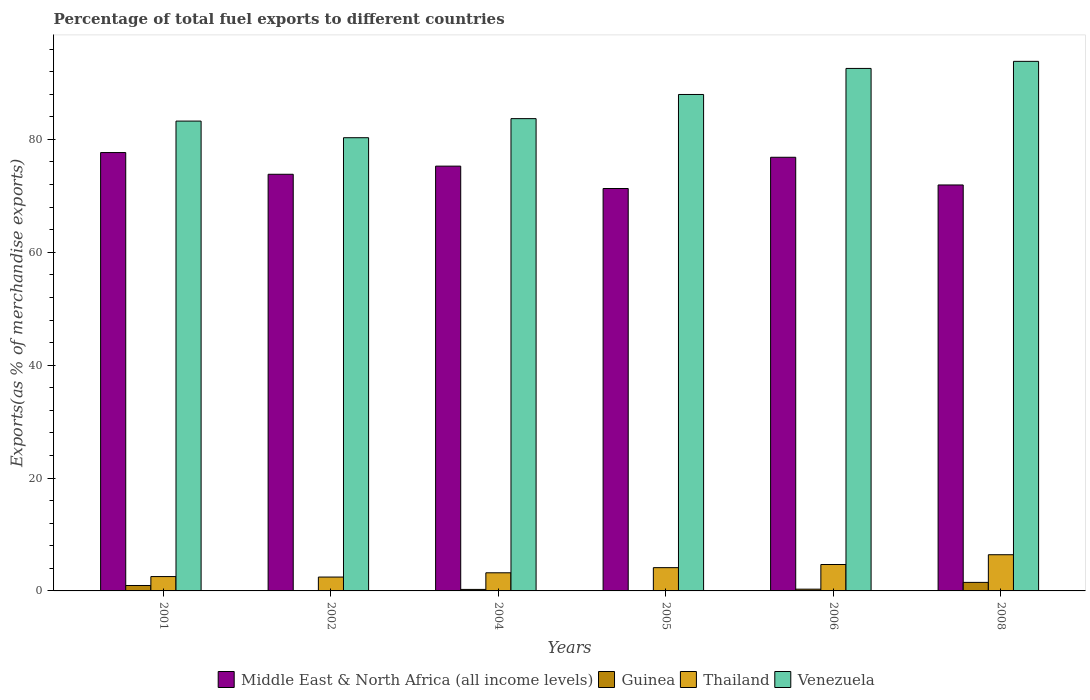How many bars are there on the 4th tick from the left?
Offer a terse response. 4. In how many cases, is the number of bars for a given year not equal to the number of legend labels?
Ensure brevity in your answer.  0. What is the percentage of exports to different countries in Middle East & North Africa (all income levels) in 2006?
Your answer should be compact. 76.83. Across all years, what is the maximum percentage of exports to different countries in Middle East & North Africa (all income levels)?
Provide a succinct answer. 77.67. Across all years, what is the minimum percentage of exports to different countries in Middle East & North Africa (all income levels)?
Give a very brief answer. 71.3. In which year was the percentage of exports to different countries in Venezuela maximum?
Provide a short and direct response. 2008. What is the total percentage of exports to different countries in Thailand in the graph?
Offer a terse response. 23.43. What is the difference between the percentage of exports to different countries in Thailand in 2001 and that in 2005?
Give a very brief answer. -1.58. What is the difference between the percentage of exports to different countries in Thailand in 2001 and the percentage of exports to different countries in Guinea in 2004?
Make the answer very short. 2.28. What is the average percentage of exports to different countries in Venezuela per year?
Offer a terse response. 86.93. In the year 2004, what is the difference between the percentage of exports to different countries in Thailand and percentage of exports to different countries in Venezuela?
Your answer should be compact. -80.47. In how many years, is the percentage of exports to different countries in Middle East & North Africa (all income levels) greater than 20 %?
Offer a terse response. 6. What is the ratio of the percentage of exports to different countries in Thailand in 2006 to that in 2008?
Keep it short and to the point. 0.73. Is the percentage of exports to different countries in Venezuela in 2001 less than that in 2008?
Offer a terse response. Yes. What is the difference between the highest and the second highest percentage of exports to different countries in Middle East & North Africa (all income levels)?
Ensure brevity in your answer.  0.84. What is the difference between the highest and the lowest percentage of exports to different countries in Thailand?
Offer a very short reply. 3.95. Is the sum of the percentage of exports to different countries in Thailand in 2004 and 2006 greater than the maximum percentage of exports to different countries in Guinea across all years?
Your answer should be compact. Yes. Is it the case that in every year, the sum of the percentage of exports to different countries in Venezuela and percentage of exports to different countries in Middle East & North Africa (all income levels) is greater than the sum of percentage of exports to different countries in Thailand and percentage of exports to different countries in Guinea?
Provide a succinct answer. No. What does the 1st bar from the left in 2008 represents?
Give a very brief answer. Middle East & North Africa (all income levels). What does the 3rd bar from the right in 2005 represents?
Make the answer very short. Guinea. Is it the case that in every year, the sum of the percentage of exports to different countries in Guinea and percentage of exports to different countries in Thailand is greater than the percentage of exports to different countries in Venezuela?
Give a very brief answer. No. How many years are there in the graph?
Your response must be concise. 6. Are the values on the major ticks of Y-axis written in scientific E-notation?
Provide a short and direct response. No. Does the graph contain any zero values?
Provide a succinct answer. No. Does the graph contain grids?
Make the answer very short. No. How many legend labels are there?
Offer a very short reply. 4. How are the legend labels stacked?
Make the answer very short. Horizontal. What is the title of the graph?
Offer a terse response. Percentage of total fuel exports to different countries. Does "Caribbean small states" appear as one of the legend labels in the graph?
Ensure brevity in your answer.  No. What is the label or title of the X-axis?
Make the answer very short. Years. What is the label or title of the Y-axis?
Ensure brevity in your answer.  Exports(as % of merchandise exports). What is the Exports(as % of merchandise exports) of Middle East & North Africa (all income levels) in 2001?
Provide a succinct answer. 77.67. What is the Exports(as % of merchandise exports) of Guinea in 2001?
Your answer should be compact. 0.96. What is the Exports(as % of merchandise exports) in Thailand in 2001?
Give a very brief answer. 2.54. What is the Exports(as % of merchandise exports) of Venezuela in 2001?
Your answer should be very brief. 83.24. What is the Exports(as % of merchandise exports) of Middle East & North Africa (all income levels) in 2002?
Keep it short and to the point. 73.82. What is the Exports(as % of merchandise exports) of Guinea in 2002?
Your answer should be compact. 0.07. What is the Exports(as % of merchandise exports) in Thailand in 2002?
Offer a terse response. 2.46. What is the Exports(as % of merchandise exports) of Venezuela in 2002?
Your answer should be compact. 80.3. What is the Exports(as % of merchandise exports) of Middle East & North Africa (all income levels) in 2004?
Keep it short and to the point. 75.26. What is the Exports(as % of merchandise exports) in Guinea in 2004?
Offer a very short reply. 0.27. What is the Exports(as % of merchandise exports) in Thailand in 2004?
Provide a short and direct response. 3.21. What is the Exports(as % of merchandise exports) of Venezuela in 2004?
Your response must be concise. 83.68. What is the Exports(as % of merchandise exports) in Middle East & North Africa (all income levels) in 2005?
Give a very brief answer. 71.3. What is the Exports(as % of merchandise exports) in Guinea in 2005?
Ensure brevity in your answer.  3.9069582544466e-5. What is the Exports(as % of merchandise exports) in Thailand in 2005?
Offer a terse response. 4.12. What is the Exports(as % of merchandise exports) of Venezuela in 2005?
Offer a terse response. 87.96. What is the Exports(as % of merchandise exports) in Middle East & North Africa (all income levels) in 2006?
Keep it short and to the point. 76.83. What is the Exports(as % of merchandise exports) in Guinea in 2006?
Ensure brevity in your answer.  0.31. What is the Exports(as % of merchandise exports) of Thailand in 2006?
Your answer should be compact. 4.68. What is the Exports(as % of merchandise exports) in Venezuela in 2006?
Ensure brevity in your answer.  92.57. What is the Exports(as % of merchandise exports) of Middle East & North Africa (all income levels) in 2008?
Provide a succinct answer. 71.93. What is the Exports(as % of merchandise exports) in Guinea in 2008?
Your answer should be very brief. 1.51. What is the Exports(as % of merchandise exports) in Thailand in 2008?
Your response must be concise. 6.41. What is the Exports(as % of merchandise exports) in Venezuela in 2008?
Give a very brief answer. 93.83. Across all years, what is the maximum Exports(as % of merchandise exports) of Middle East & North Africa (all income levels)?
Keep it short and to the point. 77.67. Across all years, what is the maximum Exports(as % of merchandise exports) in Guinea?
Provide a short and direct response. 1.51. Across all years, what is the maximum Exports(as % of merchandise exports) of Thailand?
Your response must be concise. 6.41. Across all years, what is the maximum Exports(as % of merchandise exports) of Venezuela?
Your response must be concise. 93.83. Across all years, what is the minimum Exports(as % of merchandise exports) of Middle East & North Africa (all income levels)?
Keep it short and to the point. 71.3. Across all years, what is the minimum Exports(as % of merchandise exports) in Guinea?
Keep it short and to the point. 3.9069582544466e-5. Across all years, what is the minimum Exports(as % of merchandise exports) in Thailand?
Give a very brief answer. 2.46. Across all years, what is the minimum Exports(as % of merchandise exports) in Venezuela?
Offer a terse response. 80.3. What is the total Exports(as % of merchandise exports) of Middle East & North Africa (all income levels) in the graph?
Make the answer very short. 446.81. What is the total Exports(as % of merchandise exports) in Guinea in the graph?
Your answer should be compact. 3.13. What is the total Exports(as % of merchandise exports) of Thailand in the graph?
Provide a short and direct response. 23.43. What is the total Exports(as % of merchandise exports) of Venezuela in the graph?
Your answer should be very brief. 521.58. What is the difference between the Exports(as % of merchandise exports) in Middle East & North Africa (all income levels) in 2001 and that in 2002?
Provide a succinct answer. 3.85. What is the difference between the Exports(as % of merchandise exports) in Guinea in 2001 and that in 2002?
Your response must be concise. 0.89. What is the difference between the Exports(as % of merchandise exports) of Thailand in 2001 and that in 2002?
Provide a succinct answer. 0.09. What is the difference between the Exports(as % of merchandise exports) in Venezuela in 2001 and that in 2002?
Provide a short and direct response. 2.94. What is the difference between the Exports(as % of merchandise exports) of Middle East & North Africa (all income levels) in 2001 and that in 2004?
Make the answer very short. 2.41. What is the difference between the Exports(as % of merchandise exports) in Guinea in 2001 and that in 2004?
Offer a very short reply. 0.69. What is the difference between the Exports(as % of merchandise exports) of Thailand in 2001 and that in 2004?
Provide a succinct answer. -0.67. What is the difference between the Exports(as % of merchandise exports) in Venezuela in 2001 and that in 2004?
Offer a very short reply. -0.44. What is the difference between the Exports(as % of merchandise exports) of Middle East & North Africa (all income levels) in 2001 and that in 2005?
Provide a succinct answer. 6.37. What is the difference between the Exports(as % of merchandise exports) of Guinea in 2001 and that in 2005?
Make the answer very short. 0.96. What is the difference between the Exports(as % of merchandise exports) in Thailand in 2001 and that in 2005?
Your answer should be very brief. -1.58. What is the difference between the Exports(as % of merchandise exports) of Venezuela in 2001 and that in 2005?
Provide a succinct answer. -4.71. What is the difference between the Exports(as % of merchandise exports) of Middle East & North Africa (all income levels) in 2001 and that in 2006?
Keep it short and to the point. 0.84. What is the difference between the Exports(as % of merchandise exports) of Guinea in 2001 and that in 2006?
Offer a terse response. 0.65. What is the difference between the Exports(as % of merchandise exports) of Thailand in 2001 and that in 2006?
Ensure brevity in your answer.  -2.13. What is the difference between the Exports(as % of merchandise exports) in Venezuela in 2001 and that in 2006?
Your response must be concise. -9.33. What is the difference between the Exports(as % of merchandise exports) in Middle East & North Africa (all income levels) in 2001 and that in 2008?
Offer a very short reply. 5.74. What is the difference between the Exports(as % of merchandise exports) in Guinea in 2001 and that in 2008?
Make the answer very short. -0.55. What is the difference between the Exports(as % of merchandise exports) in Thailand in 2001 and that in 2008?
Offer a terse response. -3.87. What is the difference between the Exports(as % of merchandise exports) in Venezuela in 2001 and that in 2008?
Provide a short and direct response. -10.58. What is the difference between the Exports(as % of merchandise exports) of Middle East & North Africa (all income levels) in 2002 and that in 2004?
Give a very brief answer. -1.44. What is the difference between the Exports(as % of merchandise exports) of Guinea in 2002 and that in 2004?
Keep it short and to the point. -0.19. What is the difference between the Exports(as % of merchandise exports) of Thailand in 2002 and that in 2004?
Keep it short and to the point. -0.76. What is the difference between the Exports(as % of merchandise exports) in Venezuela in 2002 and that in 2004?
Offer a very short reply. -3.38. What is the difference between the Exports(as % of merchandise exports) in Middle East & North Africa (all income levels) in 2002 and that in 2005?
Give a very brief answer. 2.52. What is the difference between the Exports(as % of merchandise exports) of Guinea in 2002 and that in 2005?
Give a very brief answer. 0.07. What is the difference between the Exports(as % of merchandise exports) of Thailand in 2002 and that in 2005?
Give a very brief answer. -1.67. What is the difference between the Exports(as % of merchandise exports) in Venezuela in 2002 and that in 2005?
Your answer should be very brief. -7.66. What is the difference between the Exports(as % of merchandise exports) in Middle East & North Africa (all income levels) in 2002 and that in 2006?
Give a very brief answer. -3.01. What is the difference between the Exports(as % of merchandise exports) in Guinea in 2002 and that in 2006?
Your answer should be compact. -0.24. What is the difference between the Exports(as % of merchandise exports) of Thailand in 2002 and that in 2006?
Provide a short and direct response. -2.22. What is the difference between the Exports(as % of merchandise exports) of Venezuela in 2002 and that in 2006?
Keep it short and to the point. -12.27. What is the difference between the Exports(as % of merchandise exports) in Middle East & North Africa (all income levels) in 2002 and that in 2008?
Offer a very short reply. 1.89. What is the difference between the Exports(as % of merchandise exports) of Guinea in 2002 and that in 2008?
Provide a short and direct response. -1.44. What is the difference between the Exports(as % of merchandise exports) of Thailand in 2002 and that in 2008?
Ensure brevity in your answer.  -3.95. What is the difference between the Exports(as % of merchandise exports) of Venezuela in 2002 and that in 2008?
Offer a very short reply. -13.53. What is the difference between the Exports(as % of merchandise exports) in Middle East & North Africa (all income levels) in 2004 and that in 2005?
Make the answer very short. 3.96. What is the difference between the Exports(as % of merchandise exports) of Guinea in 2004 and that in 2005?
Your answer should be compact. 0.27. What is the difference between the Exports(as % of merchandise exports) in Thailand in 2004 and that in 2005?
Offer a terse response. -0.91. What is the difference between the Exports(as % of merchandise exports) in Venezuela in 2004 and that in 2005?
Your answer should be very brief. -4.28. What is the difference between the Exports(as % of merchandise exports) in Middle East & North Africa (all income levels) in 2004 and that in 2006?
Offer a terse response. -1.57. What is the difference between the Exports(as % of merchandise exports) in Guinea in 2004 and that in 2006?
Your answer should be very brief. -0.04. What is the difference between the Exports(as % of merchandise exports) of Thailand in 2004 and that in 2006?
Make the answer very short. -1.47. What is the difference between the Exports(as % of merchandise exports) of Venezuela in 2004 and that in 2006?
Offer a very short reply. -8.89. What is the difference between the Exports(as % of merchandise exports) in Middle East & North Africa (all income levels) in 2004 and that in 2008?
Make the answer very short. 3.34. What is the difference between the Exports(as % of merchandise exports) of Guinea in 2004 and that in 2008?
Your answer should be very brief. -1.24. What is the difference between the Exports(as % of merchandise exports) in Thailand in 2004 and that in 2008?
Make the answer very short. -3.2. What is the difference between the Exports(as % of merchandise exports) in Venezuela in 2004 and that in 2008?
Make the answer very short. -10.15. What is the difference between the Exports(as % of merchandise exports) of Middle East & North Africa (all income levels) in 2005 and that in 2006?
Provide a short and direct response. -5.53. What is the difference between the Exports(as % of merchandise exports) in Guinea in 2005 and that in 2006?
Provide a short and direct response. -0.31. What is the difference between the Exports(as % of merchandise exports) in Thailand in 2005 and that in 2006?
Keep it short and to the point. -0.56. What is the difference between the Exports(as % of merchandise exports) of Venezuela in 2005 and that in 2006?
Keep it short and to the point. -4.62. What is the difference between the Exports(as % of merchandise exports) of Middle East & North Africa (all income levels) in 2005 and that in 2008?
Provide a short and direct response. -0.63. What is the difference between the Exports(as % of merchandise exports) in Guinea in 2005 and that in 2008?
Ensure brevity in your answer.  -1.51. What is the difference between the Exports(as % of merchandise exports) of Thailand in 2005 and that in 2008?
Provide a succinct answer. -2.29. What is the difference between the Exports(as % of merchandise exports) in Venezuela in 2005 and that in 2008?
Offer a terse response. -5.87. What is the difference between the Exports(as % of merchandise exports) in Middle East & North Africa (all income levels) in 2006 and that in 2008?
Provide a short and direct response. 4.91. What is the difference between the Exports(as % of merchandise exports) of Guinea in 2006 and that in 2008?
Provide a short and direct response. -1.2. What is the difference between the Exports(as % of merchandise exports) in Thailand in 2006 and that in 2008?
Your answer should be very brief. -1.73. What is the difference between the Exports(as % of merchandise exports) in Venezuela in 2006 and that in 2008?
Give a very brief answer. -1.25. What is the difference between the Exports(as % of merchandise exports) of Middle East & North Africa (all income levels) in 2001 and the Exports(as % of merchandise exports) of Guinea in 2002?
Offer a very short reply. 77.6. What is the difference between the Exports(as % of merchandise exports) in Middle East & North Africa (all income levels) in 2001 and the Exports(as % of merchandise exports) in Thailand in 2002?
Your response must be concise. 75.21. What is the difference between the Exports(as % of merchandise exports) of Middle East & North Africa (all income levels) in 2001 and the Exports(as % of merchandise exports) of Venezuela in 2002?
Keep it short and to the point. -2.63. What is the difference between the Exports(as % of merchandise exports) of Guinea in 2001 and the Exports(as % of merchandise exports) of Thailand in 2002?
Give a very brief answer. -1.49. What is the difference between the Exports(as % of merchandise exports) of Guinea in 2001 and the Exports(as % of merchandise exports) of Venezuela in 2002?
Make the answer very short. -79.34. What is the difference between the Exports(as % of merchandise exports) in Thailand in 2001 and the Exports(as % of merchandise exports) in Venezuela in 2002?
Ensure brevity in your answer.  -77.76. What is the difference between the Exports(as % of merchandise exports) in Middle East & North Africa (all income levels) in 2001 and the Exports(as % of merchandise exports) in Guinea in 2004?
Offer a terse response. 77.4. What is the difference between the Exports(as % of merchandise exports) in Middle East & North Africa (all income levels) in 2001 and the Exports(as % of merchandise exports) in Thailand in 2004?
Your answer should be very brief. 74.46. What is the difference between the Exports(as % of merchandise exports) in Middle East & North Africa (all income levels) in 2001 and the Exports(as % of merchandise exports) in Venezuela in 2004?
Your answer should be compact. -6.01. What is the difference between the Exports(as % of merchandise exports) of Guinea in 2001 and the Exports(as % of merchandise exports) of Thailand in 2004?
Give a very brief answer. -2.25. What is the difference between the Exports(as % of merchandise exports) of Guinea in 2001 and the Exports(as % of merchandise exports) of Venezuela in 2004?
Give a very brief answer. -82.72. What is the difference between the Exports(as % of merchandise exports) in Thailand in 2001 and the Exports(as % of merchandise exports) in Venezuela in 2004?
Your response must be concise. -81.14. What is the difference between the Exports(as % of merchandise exports) of Middle East & North Africa (all income levels) in 2001 and the Exports(as % of merchandise exports) of Guinea in 2005?
Provide a short and direct response. 77.67. What is the difference between the Exports(as % of merchandise exports) of Middle East & North Africa (all income levels) in 2001 and the Exports(as % of merchandise exports) of Thailand in 2005?
Provide a succinct answer. 73.55. What is the difference between the Exports(as % of merchandise exports) in Middle East & North Africa (all income levels) in 2001 and the Exports(as % of merchandise exports) in Venezuela in 2005?
Provide a succinct answer. -10.29. What is the difference between the Exports(as % of merchandise exports) of Guinea in 2001 and the Exports(as % of merchandise exports) of Thailand in 2005?
Your response must be concise. -3.16. What is the difference between the Exports(as % of merchandise exports) in Guinea in 2001 and the Exports(as % of merchandise exports) in Venezuela in 2005?
Keep it short and to the point. -87. What is the difference between the Exports(as % of merchandise exports) of Thailand in 2001 and the Exports(as % of merchandise exports) of Venezuela in 2005?
Your response must be concise. -85.41. What is the difference between the Exports(as % of merchandise exports) of Middle East & North Africa (all income levels) in 2001 and the Exports(as % of merchandise exports) of Guinea in 2006?
Offer a terse response. 77.36. What is the difference between the Exports(as % of merchandise exports) in Middle East & North Africa (all income levels) in 2001 and the Exports(as % of merchandise exports) in Thailand in 2006?
Give a very brief answer. 72.99. What is the difference between the Exports(as % of merchandise exports) in Middle East & North Africa (all income levels) in 2001 and the Exports(as % of merchandise exports) in Venezuela in 2006?
Offer a terse response. -14.9. What is the difference between the Exports(as % of merchandise exports) of Guinea in 2001 and the Exports(as % of merchandise exports) of Thailand in 2006?
Keep it short and to the point. -3.72. What is the difference between the Exports(as % of merchandise exports) of Guinea in 2001 and the Exports(as % of merchandise exports) of Venezuela in 2006?
Provide a short and direct response. -91.61. What is the difference between the Exports(as % of merchandise exports) in Thailand in 2001 and the Exports(as % of merchandise exports) in Venezuela in 2006?
Provide a succinct answer. -90.03. What is the difference between the Exports(as % of merchandise exports) of Middle East & North Africa (all income levels) in 2001 and the Exports(as % of merchandise exports) of Guinea in 2008?
Keep it short and to the point. 76.16. What is the difference between the Exports(as % of merchandise exports) in Middle East & North Africa (all income levels) in 2001 and the Exports(as % of merchandise exports) in Thailand in 2008?
Ensure brevity in your answer.  71.26. What is the difference between the Exports(as % of merchandise exports) in Middle East & North Africa (all income levels) in 2001 and the Exports(as % of merchandise exports) in Venezuela in 2008?
Your answer should be compact. -16.16. What is the difference between the Exports(as % of merchandise exports) of Guinea in 2001 and the Exports(as % of merchandise exports) of Thailand in 2008?
Your response must be concise. -5.45. What is the difference between the Exports(as % of merchandise exports) of Guinea in 2001 and the Exports(as % of merchandise exports) of Venezuela in 2008?
Provide a short and direct response. -92.87. What is the difference between the Exports(as % of merchandise exports) of Thailand in 2001 and the Exports(as % of merchandise exports) of Venezuela in 2008?
Offer a terse response. -91.28. What is the difference between the Exports(as % of merchandise exports) of Middle East & North Africa (all income levels) in 2002 and the Exports(as % of merchandise exports) of Guinea in 2004?
Provide a short and direct response. 73.55. What is the difference between the Exports(as % of merchandise exports) in Middle East & North Africa (all income levels) in 2002 and the Exports(as % of merchandise exports) in Thailand in 2004?
Ensure brevity in your answer.  70.61. What is the difference between the Exports(as % of merchandise exports) of Middle East & North Africa (all income levels) in 2002 and the Exports(as % of merchandise exports) of Venezuela in 2004?
Your answer should be compact. -9.86. What is the difference between the Exports(as % of merchandise exports) of Guinea in 2002 and the Exports(as % of merchandise exports) of Thailand in 2004?
Your answer should be very brief. -3.14. What is the difference between the Exports(as % of merchandise exports) in Guinea in 2002 and the Exports(as % of merchandise exports) in Venezuela in 2004?
Your answer should be compact. -83.61. What is the difference between the Exports(as % of merchandise exports) in Thailand in 2002 and the Exports(as % of merchandise exports) in Venezuela in 2004?
Give a very brief answer. -81.22. What is the difference between the Exports(as % of merchandise exports) of Middle East & North Africa (all income levels) in 2002 and the Exports(as % of merchandise exports) of Guinea in 2005?
Your answer should be very brief. 73.82. What is the difference between the Exports(as % of merchandise exports) in Middle East & North Africa (all income levels) in 2002 and the Exports(as % of merchandise exports) in Thailand in 2005?
Give a very brief answer. 69.7. What is the difference between the Exports(as % of merchandise exports) in Middle East & North Africa (all income levels) in 2002 and the Exports(as % of merchandise exports) in Venezuela in 2005?
Offer a terse response. -14.14. What is the difference between the Exports(as % of merchandise exports) of Guinea in 2002 and the Exports(as % of merchandise exports) of Thailand in 2005?
Make the answer very short. -4.05. What is the difference between the Exports(as % of merchandise exports) of Guinea in 2002 and the Exports(as % of merchandise exports) of Venezuela in 2005?
Offer a very short reply. -87.88. What is the difference between the Exports(as % of merchandise exports) of Thailand in 2002 and the Exports(as % of merchandise exports) of Venezuela in 2005?
Offer a very short reply. -85.5. What is the difference between the Exports(as % of merchandise exports) of Middle East & North Africa (all income levels) in 2002 and the Exports(as % of merchandise exports) of Guinea in 2006?
Offer a very short reply. 73.51. What is the difference between the Exports(as % of merchandise exports) of Middle East & North Africa (all income levels) in 2002 and the Exports(as % of merchandise exports) of Thailand in 2006?
Keep it short and to the point. 69.14. What is the difference between the Exports(as % of merchandise exports) in Middle East & North Africa (all income levels) in 2002 and the Exports(as % of merchandise exports) in Venezuela in 2006?
Make the answer very short. -18.75. What is the difference between the Exports(as % of merchandise exports) in Guinea in 2002 and the Exports(as % of merchandise exports) in Thailand in 2006?
Your answer should be very brief. -4.61. What is the difference between the Exports(as % of merchandise exports) in Guinea in 2002 and the Exports(as % of merchandise exports) in Venezuela in 2006?
Your answer should be very brief. -92.5. What is the difference between the Exports(as % of merchandise exports) of Thailand in 2002 and the Exports(as % of merchandise exports) of Venezuela in 2006?
Make the answer very short. -90.12. What is the difference between the Exports(as % of merchandise exports) of Middle East & North Africa (all income levels) in 2002 and the Exports(as % of merchandise exports) of Guinea in 2008?
Make the answer very short. 72.31. What is the difference between the Exports(as % of merchandise exports) in Middle East & North Africa (all income levels) in 2002 and the Exports(as % of merchandise exports) in Thailand in 2008?
Give a very brief answer. 67.41. What is the difference between the Exports(as % of merchandise exports) in Middle East & North Africa (all income levels) in 2002 and the Exports(as % of merchandise exports) in Venezuela in 2008?
Offer a very short reply. -20.01. What is the difference between the Exports(as % of merchandise exports) in Guinea in 2002 and the Exports(as % of merchandise exports) in Thailand in 2008?
Provide a short and direct response. -6.34. What is the difference between the Exports(as % of merchandise exports) of Guinea in 2002 and the Exports(as % of merchandise exports) of Venezuela in 2008?
Give a very brief answer. -93.75. What is the difference between the Exports(as % of merchandise exports) of Thailand in 2002 and the Exports(as % of merchandise exports) of Venezuela in 2008?
Provide a succinct answer. -91.37. What is the difference between the Exports(as % of merchandise exports) in Middle East & North Africa (all income levels) in 2004 and the Exports(as % of merchandise exports) in Guinea in 2005?
Keep it short and to the point. 75.26. What is the difference between the Exports(as % of merchandise exports) of Middle East & North Africa (all income levels) in 2004 and the Exports(as % of merchandise exports) of Thailand in 2005?
Provide a succinct answer. 71.14. What is the difference between the Exports(as % of merchandise exports) in Middle East & North Africa (all income levels) in 2004 and the Exports(as % of merchandise exports) in Venezuela in 2005?
Ensure brevity in your answer.  -12.7. What is the difference between the Exports(as % of merchandise exports) in Guinea in 2004 and the Exports(as % of merchandise exports) in Thailand in 2005?
Your answer should be very brief. -3.85. What is the difference between the Exports(as % of merchandise exports) in Guinea in 2004 and the Exports(as % of merchandise exports) in Venezuela in 2005?
Provide a short and direct response. -87.69. What is the difference between the Exports(as % of merchandise exports) in Thailand in 2004 and the Exports(as % of merchandise exports) in Venezuela in 2005?
Keep it short and to the point. -84.75. What is the difference between the Exports(as % of merchandise exports) of Middle East & North Africa (all income levels) in 2004 and the Exports(as % of merchandise exports) of Guinea in 2006?
Provide a succinct answer. 74.95. What is the difference between the Exports(as % of merchandise exports) in Middle East & North Africa (all income levels) in 2004 and the Exports(as % of merchandise exports) in Thailand in 2006?
Offer a very short reply. 70.58. What is the difference between the Exports(as % of merchandise exports) in Middle East & North Africa (all income levels) in 2004 and the Exports(as % of merchandise exports) in Venezuela in 2006?
Your response must be concise. -17.31. What is the difference between the Exports(as % of merchandise exports) in Guinea in 2004 and the Exports(as % of merchandise exports) in Thailand in 2006?
Your answer should be compact. -4.41. What is the difference between the Exports(as % of merchandise exports) of Guinea in 2004 and the Exports(as % of merchandise exports) of Venezuela in 2006?
Give a very brief answer. -92.31. What is the difference between the Exports(as % of merchandise exports) in Thailand in 2004 and the Exports(as % of merchandise exports) in Venezuela in 2006?
Offer a terse response. -89.36. What is the difference between the Exports(as % of merchandise exports) in Middle East & North Africa (all income levels) in 2004 and the Exports(as % of merchandise exports) in Guinea in 2008?
Provide a succinct answer. 73.75. What is the difference between the Exports(as % of merchandise exports) in Middle East & North Africa (all income levels) in 2004 and the Exports(as % of merchandise exports) in Thailand in 2008?
Keep it short and to the point. 68.85. What is the difference between the Exports(as % of merchandise exports) of Middle East & North Africa (all income levels) in 2004 and the Exports(as % of merchandise exports) of Venezuela in 2008?
Offer a very short reply. -18.57. What is the difference between the Exports(as % of merchandise exports) of Guinea in 2004 and the Exports(as % of merchandise exports) of Thailand in 2008?
Give a very brief answer. -6.14. What is the difference between the Exports(as % of merchandise exports) in Guinea in 2004 and the Exports(as % of merchandise exports) in Venezuela in 2008?
Offer a very short reply. -93.56. What is the difference between the Exports(as % of merchandise exports) of Thailand in 2004 and the Exports(as % of merchandise exports) of Venezuela in 2008?
Provide a succinct answer. -90.61. What is the difference between the Exports(as % of merchandise exports) of Middle East & North Africa (all income levels) in 2005 and the Exports(as % of merchandise exports) of Guinea in 2006?
Give a very brief answer. 70.99. What is the difference between the Exports(as % of merchandise exports) in Middle East & North Africa (all income levels) in 2005 and the Exports(as % of merchandise exports) in Thailand in 2006?
Your response must be concise. 66.62. What is the difference between the Exports(as % of merchandise exports) in Middle East & North Africa (all income levels) in 2005 and the Exports(as % of merchandise exports) in Venezuela in 2006?
Your response must be concise. -21.27. What is the difference between the Exports(as % of merchandise exports) of Guinea in 2005 and the Exports(as % of merchandise exports) of Thailand in 2006?
Give a very brief answer. -4.68. What is the difference between the Exports(as % of merchandise exports) in Guinea in 2005 and the Exports(as % of merchandise exports) in Venezuela in 2006?
Ensure brevity in your answer.  -92.57. What is the difference between the Exports(as % of merchandise exports) in Thailand in 2005 and the Exports(as % of merchandise exports) in Venezuela in 2006?
Give a very brief answer. -88.45. What is the difference between the Exports(as % of merchandise exports) of Middle East & North Africa (all income levels) in 2005 and the Exports(as % of merchandise exports) of Guinea in 2008?
Your answer should be very brief. 69.79. What is the difference between the Exports(as % of merchandise exports) in Middle East & North Africa (all income levels) in 2005 and the Exports(as % of merchandise exports) in Thailand in 2008?
Ensure brevity in your answer.  64.89. What is the difference between the Exports(as % of merchandise exports) in Middle East & North Africa (all income levels) in 2005 and the Exports(as % of merchandise exports) in Venezuela in 2008?
Provide a succinct answer. -22.53. What is the difference between the Exports(as % of merchandise exports) in Guinea in 2005 and the Exports(as % of merchandise exports) in Thailand in 2008?
Ensure brevity in your answer.  -6.41. What is the difference between the Exports(as % of merchandise exports) in Guinea in 2005 and the Exports(as % of merchandise exports) in Venezuela in 2008?
Give a very brief answer. -93.83. What is the difference between the Exports(as % of merchandise exports) of Thailand in 2005 and the Exports(as % of merchandise exports) of Venezuela in 2008?
Your response must be concise. -89.71. What is the difference between the Exports(as % of merchandise exports) in Middle East & North Africa (all income levels) in 2006 and the Exports(as % of merchandise exports) in Guinea in 2008?
Ensure brevity in your answer.  75.32. What is the difference between the Exports(as % of merchandise exports) of Middle East & North Africa (all income levels) in 2006 and the Exports(as % of merchandise exports) of Thailand in 2008?
Ensure brevity in your answer.  70.42. What is the difference between the Exports(as % of merchandise exports) in Middle East & North Africa (all income levels) in 2006 and the Exports(as % of merchandise exports) in Venezuela in 2008?
Give a very brief answer. -17. What is the difference between the Exports(as % of merchandise exports) of Guinea in 2006 and the Exports(as % of merchandise exports) of Thailand in 2008?
Offer a terse response. -6.1. What is the difference between the Exports(as % of merchandise exports) in Guinea in 2006 and the Exports(as % of merchandise exports) in Venezuela in 2008?
Ensure brevity in your answer.  -93.52. What is the difference between the Exports(as % of merchandise exports) of Thailand in 2006 and the Exports(as % of merchandise exports) of Venezuela in 2008?
Offer a very short reply. -89.15. What is the average Exports(as % of merchandise exports) in Middle East & North Africa (all income levels) per year?
Ensure brevity in your answer.  74.47. What is the average Exports(as % of merchandise exports) in Guinea per year?
Offer a very short reply. 0.52. What is the average Exports(as % of merchandise exports) of Thailand per year?
Offer a terse response. 3.9. What is the average Exports(as % of merchandise exports) of Venezuela per year?
Ensure brevity in your answer.  86.93. In the year 2001, what is the difference between the Exports(as % of merchandise exports) in Middle East & North Africa (all income levels) and Exports(as % of merchandise exports) in Guinea?
Provide a short and direct response. 76.71. In the year 2001, what is the difference between the Exports(as % of merchandise exports) of Middle East & North Africa (all income levels) and Exports(as % of merchandise exports) of Thailand?
Provide a succinct answer. 75.12. In the year 2001, what is the difference between the Exports(as % of merchandise exports) of Middle East & North Africa (all income levels) and Exports(as % of merchandise exports) of Venezuela?
Keep it short and to the point. -5.57. In the year 2001, what is the difference between the Exports(as % of merchandise exports) in Guinea and Exports(as % of merchandise exports) in Thailand?
Your answer should be very brief. -1.58. In the year 2001, what is the difference between the Exports(as % of merchandise exports) of Guinea and Exports(as % of merchandise exports) of Venezuela?
Your answer should be very brief. -82.28. In the year 2001, what is the difference between the Exports(as % of merchandise exports) in Thailand and Exports(as % of merchandise exports) in Venezuela?
Provide a succinct answer. -80.7. In the year 2002, what is the difference between the Exports(as % of merchandise exports) of Middle East & North Africa (all income levels) and Exports(as % of merchandise exports) of Guinea?
Ensure brevity in your answer.  73.75. In the year 2002, what is the difference between the Exports(as % of merchandise exports) in Middle East & North Africa (all income levels) and Exports(as % of merchandise exports) in Thailand?
Provide a short and direct response. 71.36. In the year 2002, what is the difference between the Exports(as % of merchandise exports) in Middle East & North Africa (all income levels) and Exports(as % of merchandise exports) in Venezuela?
Make the answer very short. -6.48. In the year 2002, what is the difference between the Exports(as % of merchandise exports) of Guinea and Exports(as % of merchandise exports) of Thailand?
Your response must be concise. -2.38. In the year 2002, what is the difference between the Exports(as % of merchandise exports) in Guinea and Exports(as % of merchandise exports) in Venezuela?
Offer a terse response. -80.23. In the year 2002, what is the difference between the Exports(as % of merchandise exports) in Thailand and Exports(as % of merchandise exports) in Venezuela?
Your response must be concise. -77.84. In the year 2004, what is the difference between the Exports(as % of merchandise exports) in Middle East & North Africa (all income levels) and Exports(as % of merchandise exports) in Guinea?
Provide a short and direct response. 74.99. In the year 2004, what is the difference between the Exports(as % of merchandise exports) of Middle East & North Africa (all income levels) and Exports(as % of merchandise exports) of Thailand?
Your answer should be very brief. 72.05. In the year 2004, what is the difference between the Exports(as % of merchandise exports) in Middle East & North Africa (all income levels) and Exports(as % of merchandise exports) in Venezuela?
Your response must be concise. -8.42. In the year 2004, what is the difference between the Exports(as % of merchandise exports) of Guinea and Exports(as % of merchandise exports) of Thailand?
Ensure brevity in your answer.  -2.94. In the year 2004, what is the difference between the Exports(as % of merchandise exports) of Guinea and Exports(as % of merchandise exports) of Venezuela?
Offer a terse response. -83.41. In the year 2004, what is the difference between the Exports(as % of merchandise exports) of Thailand and Exports(as % of merchandise exports) of Venezuela?
Give a very brief answer. -80.47. In the year 2005, what is the difference between the Exports(as % of merchandise exports) in Middle East & North Africa (all income levels) and Exports(as % of merchandise exports) in Guinea?
Offer a very short reply. 71.3. In the year 2005, what is the difference between the Exports(as % of merchandise exports) of Middle East & North Africa (all income levels) and Exports(as % of merchandise exports) of Thailand?
Your answer should be compact. 67.18. In the year 2005, what is the difference between the Exports(as % of merchandise exports) of Middle East & North Africa (all income levels) and Exports(as % of merchandise exports) of Venezuela?
Your answer should be compact. -16.66. In the year 2005, what is the difference between the Exports(as % of merchandise exports) in Guinea and Exports(as % of merchandise exports) in Thailand?
Provide a succinct answer. -4.12. In the year 2005, what is the difference between the Exports(as % of merchandise exports) in Guinea and Exports(as % of merchandise exports) in Venezuela?
Your answer should be very brief. -87.96. In the year 2005, what is the difference between the Exports(as % of merchandise exports) in Thailand and Exports(as % of merchandise exports) in Venezuela?
Offer a terse response. -83.84. In the year 2006, what is the difference between the Exports(as % of merchandise exports) in Middle East & North Africa (all income levels) and Exports(as % of merchandise exports) in Guinea?
Make the answer very short. 76.52. In the year 2006, what is the difference between the Exports(as % of merchandise exports) in Middle East & North Africa (all income levels) and Exports(as % of merchandise exports) in Thailand?
Keep it short and to the point. 72.15. In the year 2006, what is the difference between the Exports(as % of merchandise exports) in Middle East & North Africa (all income levels) and Exports(as % of merchandise exports) in Venezuela?
Your response must be concise. -15.74. In the year 2006, what is the difference between the Exports(as % of merchandise exports) in Guinea and Exports(as % of merchandise exports) in Thailand?
Keep it short and to the point. -4.37. In the year 2006, what is the difference between the Exports(as % of merchandise exports) of Guinea and Exports(as % of merchandise exports) of Venezuela?
Your response must be concise. -92.26. In the year 2006, what is the difference between the Exports(as % of merchandise exports) of Thailand and Exports(as % of merchandise exports) of Venezuela?
Your answer should be very brief. -87.89. In the year 2008, what is the difference between the Exports(as % of merchandise exports) in Middle East & North Africa (all income levels) and Exports(as % of merchandise exports) in Guinea?
Provide a short and direct response. 70.41. In the year 2008, what is the difference between the Exports(as % of merchandise exports) in Middle East & North Africa (all income levels) and Exports(as % of merchandise exports) in Thailand?
Ensure brevity in your answer.  65.51. In the year 2008, what is the difference between the Exports(as % of merchandise exports) in Middle East & North Africa (all income levels) and Exports(as % of merchandise exports) in Venezuela?
Keep it short and to the point. -21.9. In the year 2008, what is the difference between the Exports(as % of merchandise exports) of Guinea and Exports(as % of merchandise exports) of Thailand?
Provide a short and direct response. -4.9. In the year 2008, what is the difference between the Exports(as % of merchandise exports) in Guinea and Exports(as % of merchandise exports) in Venezuela?
Provide a succinct answer. -92.32. In the year 2008, what is the difference between the Exports(as % of merchandise exports) of Thailand and Exports(as % of merchandise exports) of Venezuela?
Offer a terse response. -87.42. What is the ratio of the Exports(as % of merchandise exports) of Middle East & North Africa (all income levels) in 2001 to that in 2002?
Offer a very short reply. 1.05. What is the ratio of the Exports(as % of merchandise exports) of Guinea in 2001 to that in 2002?
Your answer should be very brief. 13.05. What is the ratio of the Exports(as % of merchandise exports) in Thailand in 2001 to that in 2002?
Give a very brief answer. 1.04. What is the ratio of the Exports(as % of merchandise exports) in Venezuela in 2001 to that in 2002?
Make the answer very short. 1.04. What is the ratio of the Exports(as % of merchandise exports) in Middle East & North Africa (all income levels) in 2001 to that in 2004?
Your response must be concise. 1.03. What is the ratio of the Exports(as % of merchandise exports) of Guinea in 2001 to that in 2004?
Offer a very short reply. 3.59. What is the ratio of the Exports(as % of merchandise exports) of Thailand in 2001 to that in 2004?
Make the answer very short. 0.79. What is the ratio of the Exports(as % of merchandise exports) in Middle East & North Africa (all income levels) in 2001 to that in 2005?
Keep it short and to the point. 1.09. What is the ratio of the Exports(as % of merchandise exports) of Guinea in 2001 to that in 2005?
Offer a terse response. 2.46e+04. What is the ratio of the Exports(as % of merchandise exports) in Thailand in 2001 to that in 2005?
Your answer should be very brief. 0.62. What is the ratio of the Exports(as % of merchandise exports) of Venezuela in 2001 to that in 2005?
Make the answer very short. 0.95. What is the ratio of the Exports(as % of merchandise exports) in Middle East & North Africa (all income levels) in 2001 to that in 2006?
Provide a succinct answer. 1.01. What is the ratio of the Exports(as % of merchandise exports) in Guinea in 2001 to that in 2006?
Provide a succinct answer. 3.08. What is the ratio of the Exports(as % of merchandise exports) in Thailand in 2001 to that in 2006?
Provide a short and direct response. 0.54. What is the ratio of the Exports(as % of merchandise exports) in Venezuela in 2001 to that in 2006?
Ensure brevity in your answer.  0.9. What is the ratio of the Exports(as % of merchandise exports) of Middle East & North Africa (all income levels) in 2001 to that in 2008?
Your answer should be very brief. 1.08. What is the ratio of the Exports(as % of merchandise exports) in Guinea in 2001 to that in 2008?
Ensure brevity in your answer.  0.64. What is the ratio of the Exports(as % of merchandise exports) of Thailand in 2001 to that in 2008?
Your answer should be compact. 0.4. What is the ratio of the Exports(as % of merchandise exports) of Venezuela in 2001 to that in 2008?
Keep it short and to the point. 0.89. What is the ratio of the Exports(as % of merchandise exports) in Middle East & North Africa (all income levels) in 2002 to that in 2004?
Ensure brevity in your answer.  0.98. What is the ratio of the Exports(as % of merchandise exports) in Guinea in 2002 to that in 2004?
Offer a very short reply. 0.27. What is the ratio of the Exports(as % of merchandise exports) of Thailand in 2002 to that in 2004?
Make the answer very short. 0.76. What is the ratio of the Exports(as % of merchandise exports) in Venezuela in 2002 to that in 2004?
Keep it short and to the point. 0.96. What is the ratio of the Exports(as % of merchandise exports) in Middle East & North Africa (all income levels) in 2002 to that in 2005?
Your answer should be very brief. 1.04. What is the ratio of the Exports(as % of merchandise exports) of Guinea in 2002 to that in 2005?
Ensure brevity in your answer.  1887.48. What is the ratio of the Exports(as % of merchandise exports) of Thailand in 2002 to that in 2005?
Make the answer very short. 0.6. What is the ratio of the Exports(as % of merchandise exports) of Venezuela in 2002 to that in 2005?
Ensure brevity in your answer.  0.91. What is the ratio of the Exports(as % of merchandise exports) of Middle East & North Africa (all income levels) in 2002 to that in 2006?
Make the answer very short. 0.96. What is the ratio of the Exports(as % of merchandise exports) of Guinea in 2002 to that in 2006?
Offer a terse response. 0.24. What is the ratio of the Exports(as % of merchandise exports) of Thailand in 2002 to that in 2006?
Give a very brief answer. 0.53. What is the ratio of the Exports(as % of merchandise exports) of Venezuela in 2002 to that in 2006?
Make the answer very short. 0.87. What is the ratio of the Exports(as % of merchandise exports) in Middle East & North Africa (all income levels) in 2002 to that in 2008?
Ensure brevity in your answer.  1.03. What is the ratio of the Exports(as % of merchandise exports) in Guinea in 2002 to that in 2008?
Ensure brevity in your answer.  0.05. What is the ratio of the Exports(as % of merchandise exports) in Thailand in 2002 to that in 2008?
Your answer should be very brief. 0.38. What is the ratio of the Exports(as % of merchandise exports) of Venezuela in 2002 to that in 2008?
Offer a terse response. 0.86. What is the ratio of the Exports(as % of merchandise exports) of Middle East & North Africa (all income levels) in 2004 to that in 2005?
Make the answer very short. 1.06. What is the ratio of the Exports(as % of merchandise exports) in Guinea in 2004 to that in 2005?
Offer a very short reply. 6866.83. What is the ratio of the Exports(as % of merchandise exports) of Thailand in 2004 to that in 2005?
Your answer should be very brief. 0.78. What is the ratio of the Exports(as % of merchandise exports) of Venezuela in 2004 to that in 2005?
Ensure brevity in your answer.  0.95. What is the ratio of the Exports(as % of merchandise exports) of Middle East & North Africa (all income levels) in 2004 to that in 2006?
Ensure brevity in your answer.  0.98. What is the ratio of the Exports(as % of merchandise exports) of Guinea in 2004 to that in 2006?
Provide a succinct answer. 0.86. What is the ratio of the Exports(as % of merchandise exports) of Thailand in 2004 to that in 2006?
Your answer should be compact. 0.69. What is the ratio of the Exports(as % of merchandise exports) of Venezuela in 2004 to that in 2006?
Offer a terse response. 0.9. What is the ratio of the Exports(as % of merchandise exports) of Middle East & North Africa (all income levels) in 2004 to that in 2008?
Provide a short and direct response. 1.05. What is the ratio of the Exports(as % of merchandise exports) in Guinea in 2004 to that in 2008?
Keep it short and to the point. 0.18. What is the ratio of the Exports(as % of merchandise exports) of Thailand in 2004 to that in 2008?
Offer a very short reply. 0.5. What is the ratio of the Exports(as % of merchandise exports) in Venezuela in 2004 to that in 2008?
Make the answer very short. 0.89. What is the ratio of the Exports(as % of merchandise exports) in Middle East & North Africa (all income levels) in 2005 to that in 2006?
Ensure brevity in your answer.  0.93. What is the ratio of the Exports(as % of merchandise exports) in Thailand in 2005 to that in 2006?
Provide a short and direct response. 0.88. What is the ratio of the Exports(as % of merchandise exports) of Venezuela in 2005 to that in 2006?
Your answer should be compact. 0.95. What is the ratio of the Exports(as % of merchandise exports) in Middle East & North Africa (all income levels) in 2005 to that in 2008?
Make the answer very short. 0.99. What is the ratio of the Exports(as % of merchandise exports) in Thailand in 2005 to that in 2008?
Make the answer very short. 0.64. What is the ratio of the Exports(as % of merchandise exports) in Venezuela in 2005 to that in 2008?
Provide a succinct answer. 0.94. What is the ratio of the Exports(as % of merchandise exports) in Middle East & North Africa (all income levels) in 2006 to that in 2008?
Offer a very short reply. 1.07. What is the ratio of the Exports(as % of merchandise exports) in Guinea in 2006 to that in 2008?
Provide a short and direct response. 0.21. What is the ratio of the Exports(as % of merchandise exports) in Thailand in 2006 to that in 2008?
Give a very brief answer. 0.73. What is the ratio of the Exports(as % of merchandise exports) in Venezuela in 2006 to that in 2008?
Provide a succinct answer. 0.99. What is the difference between the highest and the second highest Exports(as % of merchandise exports) in Middle East & North Africa (all income levels)?
Keep it short and to the point. 0.84. What is the difference between the highest and the second highest Exports(as % of merchandise exports) of Guinea?
Make the answer very short. 0.55. What is the difference between the highest and the second highest Exports(as % of merchandise exports) of Thailand?
Provide a short and direct response. 1.73. What is the difference between the highest and the second highest Exports(as % of merchandise exports) in Venezuela?
Provide a succinct answer. 1.25. What is the difference between the highest and the lowest Exports(as % of merchandise exports) in Middle East & North Africa (all income levels)?
Give a very brief answer. 6.37. What is the difference between the highest and the lowest Exports(as % of merchandise exports) of Guinea?
Make the answer very short. 1.51. What is the difference between the highest and the lowest Exports(as % of merchandise exports) of Thailand?
Provide a short and direct response. 3.95. What is the difference between the highest and the lowest Exports(as % of merchandise exports) of Venezuela?
Your answer should be compact. 13.53. 